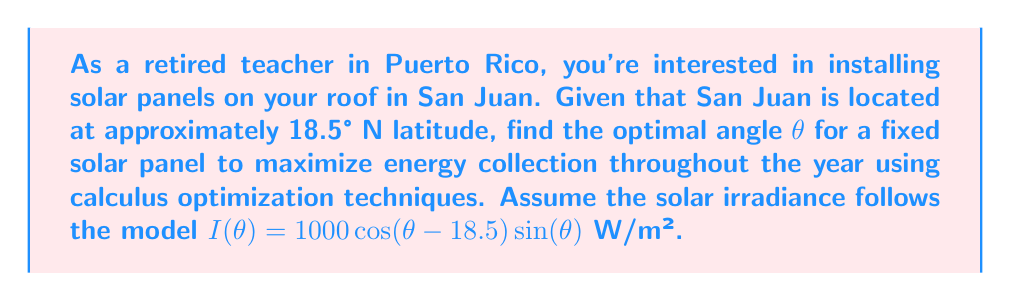Teach me how to tackle this problem. To find the optimal angle θ, we need to maximize the solar irradiance function $I(θ)$. Let's approach this step-by-step:

1) The given function is:
   $I(θ) = 1000 \cos(θ - 18.5°) \sin(θ)$

2) To find the maximum, we need to find where the derivative $\frac{dI}{dθ} = 0$:
   
   $$\frac{dI}{dθ} = 1000[\cos(θ - 18.5°) \cos(θ) - \sin(θ - 18.5°) \sin(θ)]$$

3) Set this equal to zero:
   
   $$1000[\cos(θ - 18.5°) \cos(θ) - \sin(θ - 18.5°) \sin(θ)] = 0$$

4) Simplify:
   
   $$\cos(θ - 18.5°) \cos(θ) - \sin(θ - 18.5°) \sin(θ) = 0$$

5) Recognize this as the cosine of a sum:
   
   $$\cos(2θ - 18.5°) = 0$$

6) Solve for θ:
   
   $$2θ - 18.5° = 90°$$
   $$2θ = 108.5°$$
   $$θ = 54.25°$$

7) To confirm this is a maximum (not a minimum), we can check the second derivative is negative at this point (omitted for brevity).

Therefore, the optimal angle for the solar panel in San Juan is approximately 54.25° from the horizontal.
Answer: 54.25° 